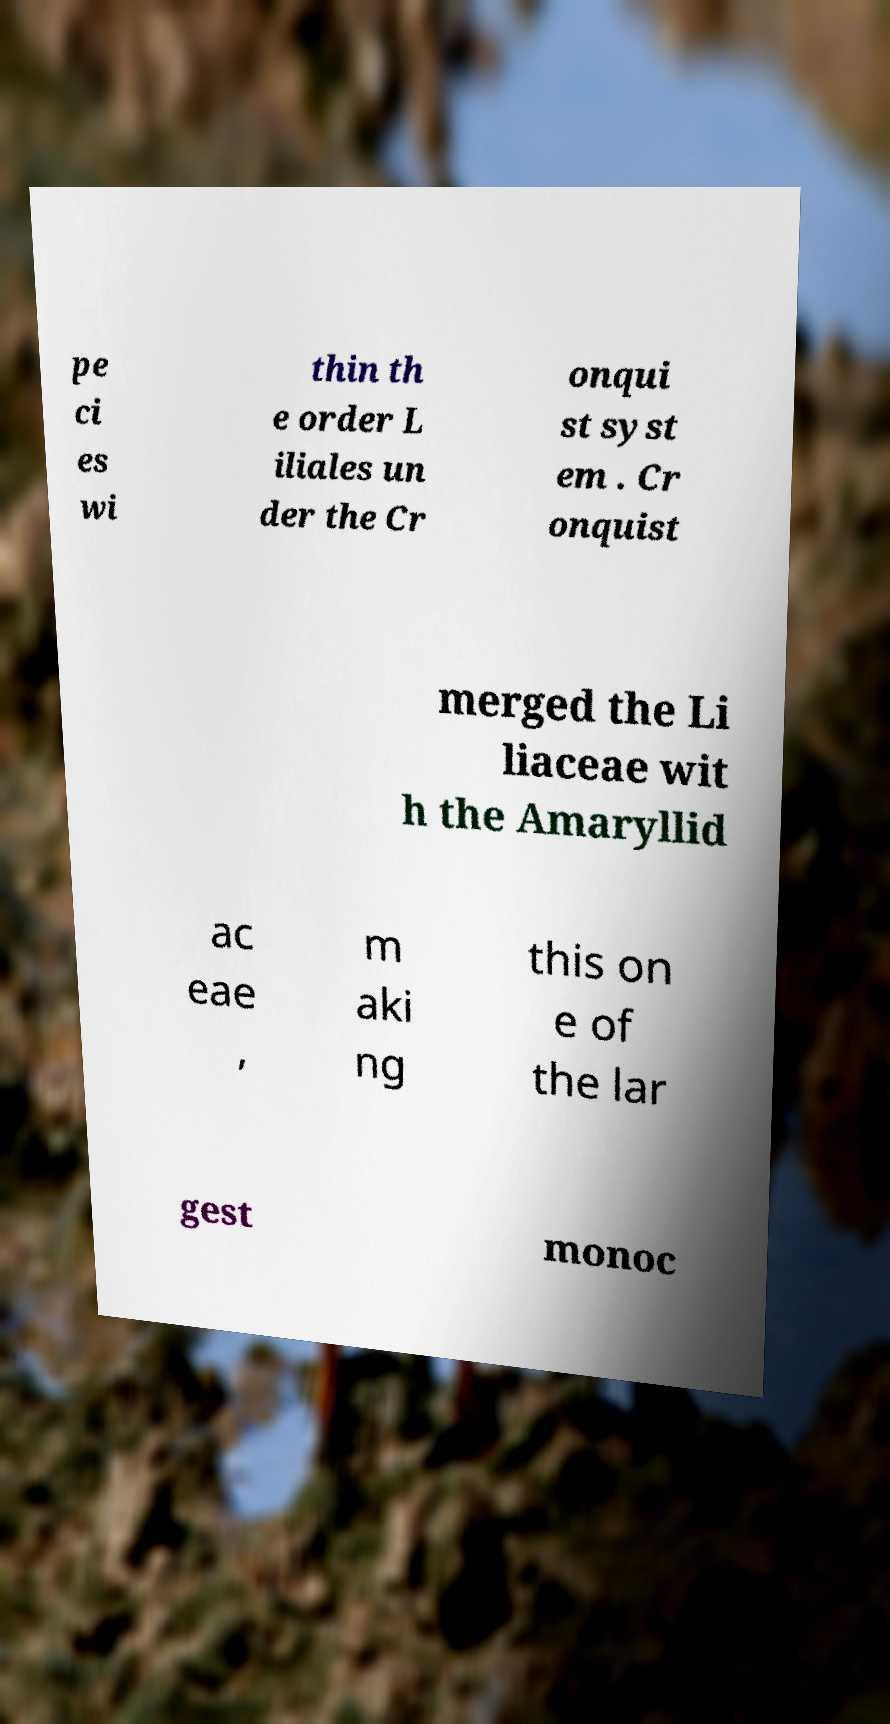Could you assist in decoding the text presented in this image and type it out clearly? pe ci es wi thin th e order L iliales un der the Cr onqui st syst em . Cr onquist merged the Li liaceae wit h the Amaryllid ac eae , m aki ng this on e of the lar gest monoc 